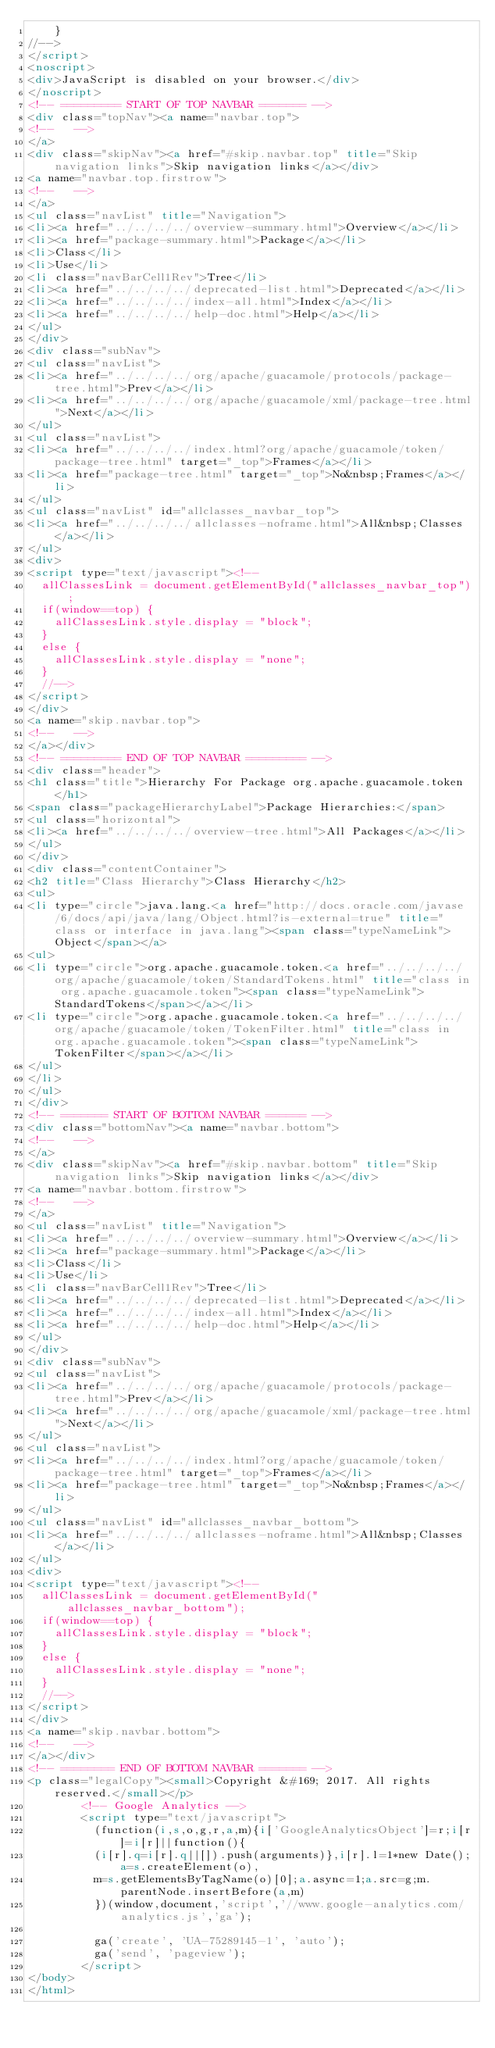<code> <loc_0><loc_0><loc_500><loc_500><_HTML_>    }
//-->
</script>
<noscript>
<div>JavaScript is disabled on your browser.</div>
</noscript>
<!-- ========= START OF TOP NAVBAR ======= -->
<div class="topNav"><a name="navbar.top">
<!--   -->
</a>
<div class="skipNav"><a href="#skip.navbar.top" title="Skip navigation links">Skip navigation links</a></div>
<a name="navbar.top.firstrow">
<!--   -->
</a>
<ul class="navList" title="Navigation">
<li><a href="../../../../overview-summary.html">Overview</a></li>
<li><a href="package-summary.html">Package</a></li>
<li>Class</li>
<li>Use</li>
<li class="navBarCell1Rev">Tree</li>
<li><a href="../../../../deprecated-list.html">Deprecated</a></li>
<li><a href="../../../../index-all.html">Index</a></li>
<li><a href="../../../../help-doc.html">Help</a></li>
</ul>
</div>
<div class="subNav">
<ul class="navList">
<li><a href="../../../../org/apache/guacamole/protocols/package-tree.html">Prev</a></li>
<li><a href="../../../../org/apache/guacamole/xml/package-tree.html">Next</a></li>
</ul>
<ul class="navList">
<li><a href="../../../../index.html?org/apache/guacamole/token/package-tree.html" target="_top">Frames</a></li>
<li><a href="package-tree.html" target="_top">No&nbsp;Frames</a></li>
</ul>
<ul class="navList" id="allclasses_navbar_top">
<li><a href="../../../../allclasses-noframe.html">All&nbsp;Classes</a></li>
</ul>
<div>
<script type="text/javascript"><!--
  allClassesLink = document.getElementById("allclasses_navbar_top");
  if(window==top) {
    allClassesLink.style.display = "block";
  }
  else {
    allClassesLink.style.display = "none";
  }
  //-->
</script>
</div>
<a name="skip.navbar.top">
<!--   -->
</a></div>
<!-- ========= END OF TOP NAVBAR ========= -->
<div class="header">
<h1 class="title">Hierarchy For Package org.apache.guacamole.token</h1>
<span class="packageHierarchyLabel">Package Hierarchies:</span>
<ul class="horizontal">
<li><a href="../../../../overview-tree.html">All Packages</a></li>
</ul>
</div>
<div class="contentContainer">
<h2 title="Class Hierarchy">Class Hierarchy</h2>
<ul>
<li type="circle">java.lang.<a href="http://docs.oracle.com/javase/6/docs/api/java/lang/Object.html?is-external=true" title="class or interface in java.lang"><span class="typeNameLink">Object</span></a>
<ul>
<li type="circle">org.apache.guacamole.token.<a href="../../../../org/apache/guacamole/token/StandardTokens.html" title="class in org.apache.guacamole.token"><span class="typeNameLink">StandardTokens</span></a></li>
<li type="circle">org.apache.guacamole.token.<a href="../../../../org/apache/guacamole/token/TokenFilter.html" title="class in org.apache.guacamole.token"><span class="typeNameLink">TokenFilter</span></a></li>
</ul>
</li>
</ul>
</div>
<!-- ======= START OF BOTTOM NAVBAR ====== -->
<div class="bottomNav"><a name="navbar.bottom">
<!--   -->
</a>
<div class="skipNav"><a href="#skip.navbar.bottom" title="Skip navigation links">Skip navigation links</a></div>
<a name="navbar.bottom.firstrow">
<!--   -->
</a>
<ul class="navList" title="Navigation">
<li><a href="../../../../overview-summary.html">Overview</a></li>
<li><a href="package-summary.html">Package</a></li>
<li>Class</li>
<li>Use</li>
<li class="navBarCell1Rev">Tree</li>
<li><a href="../../../../deprecated-list.html">Deprecated</a></li>
<li><a href="../../../../index-all.html">Index</a></li>
<li><a href="../../../../help-doc.html">Help</a></li>
</ul>
</div>
<div class="subNav">
<ul class="navList">
<li><a href="../../../../org/apache/guacamole/protocols/package-tree.html">Prev</a></li>
<li><a href="../../../../org/apache/guacamole/xml/package-tree.html">Next</a></li>
</ul>
<ul class="navList">
<li><a href="../../../../index.html?org/apache/guacamole/token/package-tree.html" target="_top">Frames</a></li>
<li><a href="package-tree.html" target="_top">No&nbsp;Frames</a></li>
</ul>
<ul class="navList" id="allclasses_navbar_bottom">
<li><a href="../../../../allclasses-noframe.html">All&nbsp;Classes</a></li>
</ul>
<div>
<script type="text/javascript"><!--
  allClassesLink = document.getElementById("allclasses_navbar_bottom");
  if(window==top) {
    allClassesLink.style.display = "block";
  }
  else {
    allClassesLink.style.display = "none";
  }
  //-->
</script>
</div>
<a name="skip.navbar.bottom">
<!--   -->
</a></div>
<!-- ======== END OF BOTTOM NAVBAR ======= -->
<p class="legalCopy"><small>Copyright &#169; 2017. All rights reserved.</small></p>
        <!-- Google Analytics -->
        <script type="text/javascript">
          (function(i,s,o,g,r,a,m){i['GoogleAnalyticsObject']=r;i[r]=i[r]||function(){
          (i[r].q=i[r].q||[]).push(arguments)},i[r].l=1*new Date();a=s.createElement(o),
          m=s.getElementsByTagName(o)[0];a.async=1;a.src=g;m.parentNode.insertBefore(a,m)
          })(window,document,'script','//www.google-analytics.com/analytics.js','ga');

          ga('create', 'UA-75289145-1', 'auto');
          ga('send', 'pageview');
        </script>
</body>
</html>
</code> 